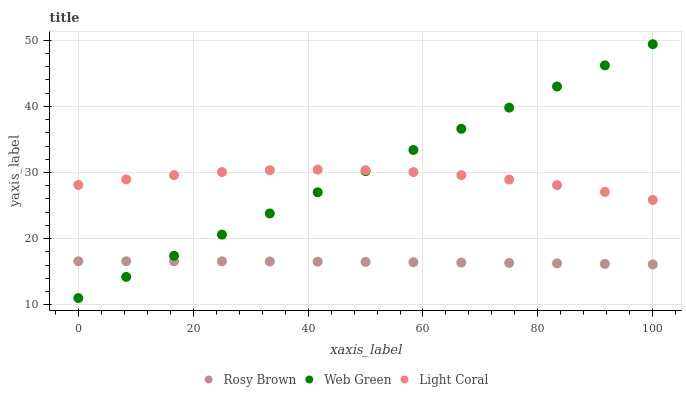Does Rosy Brown have the minimum area under the curve?
Answer yes or no. Yes. Does Web Green have the maximum area under the curve?
Answer yes or no. Yes. Does Web Green have the minimum area under the curve?
Answer yes or no. No. Does Rosy Brown have the maximum area under the curve?
Answer yes or no. No. Is Web Green the smoothest?
Answer yes or no. Yes. Is Light Coral the roughest?
Answer yes or no. Yes. Is Rosy Brown the smoothest?
Answer yes or no. No. Is Rosy Brown the roughest?
Answer yes or no. No. Does Web Green have the lowest value?
Answer yes or no. Yes. Does Rosy Brown have the lowest value?
Answer yes or no. No. Does Web Green have the highest value?
Answer yes or no. Yes. Does Rosy Brown have the highest value?
Answer yes or no. No. Is Rosy Brown less than Light Coral?
Answer yes or no. Yes. Is Light Coral greater than Rosy Brown?
Answer yes or no. Yes. Does Rosy Brown intersect Web Green?
Answer yes or no. Yes. Is Rosy Brown less than Web Green?
Answer yes or no. No. Is Rosy Brown greater than Web Green?
Answer yes or no. No. Does Rosy Brown intersect Light Coral?
Answer yes or no. No. 